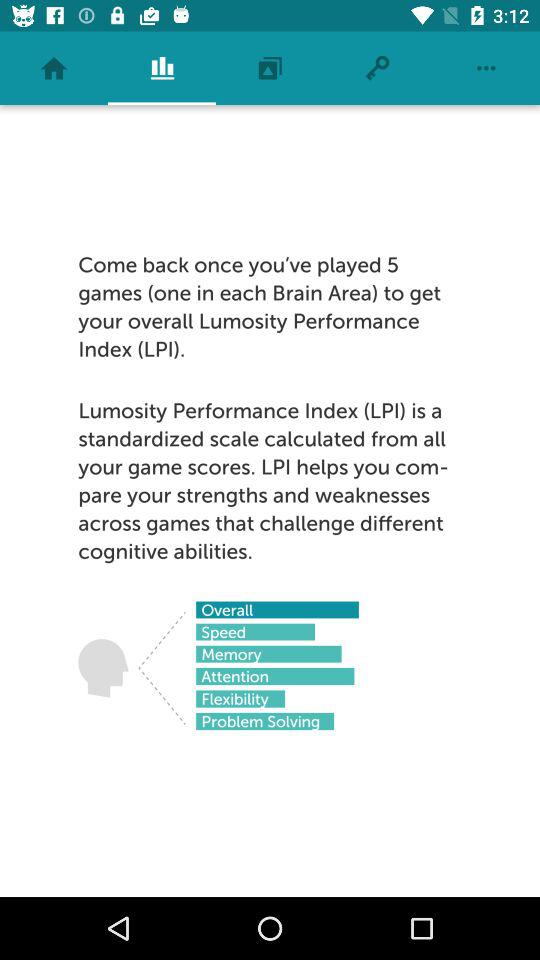How many different cognitive abilities are there?
Answer the question using a single word or phrase. 6 